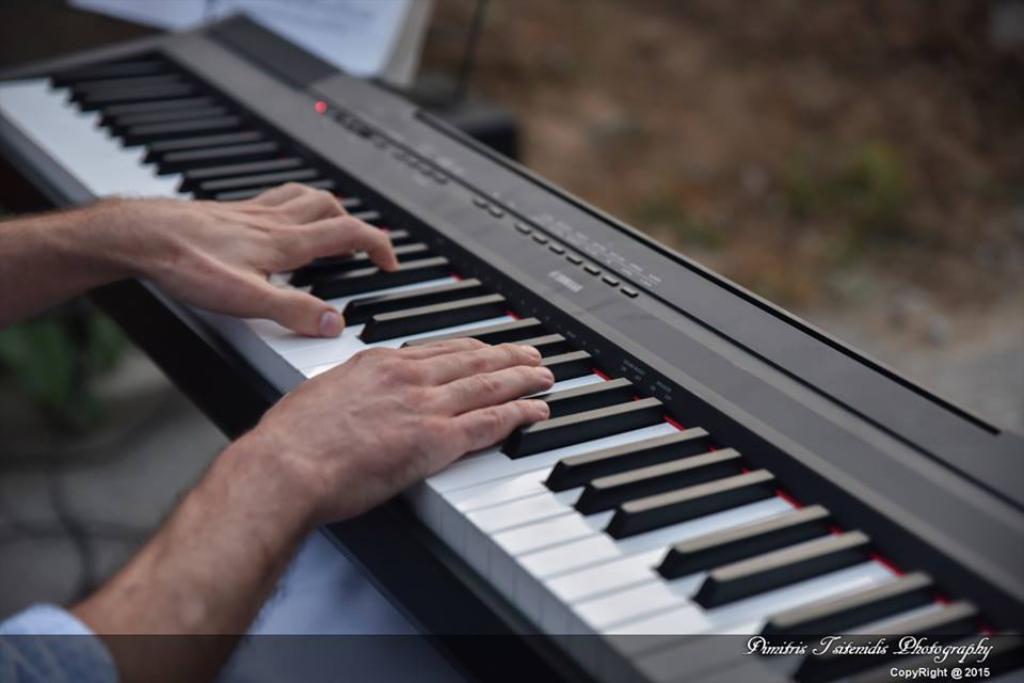Can you describe this image briefly? In this picture a person is playing keyboard. 